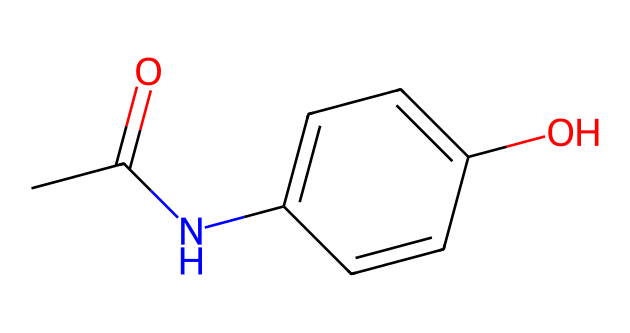What is the molecular formula of acetaminophen? The SMILES representation can be broken down to identify the components. There are two carbonyl (C) atoms from the acetyl group (CC(=O)) and a phenolic hydroxyl group (c1ccc(O)cc). Counting all atoms gives C8, H9, N1, O2. Therefore, the molecular formula is C8H9NO2.
Answer: C8H9NO2 How many rings are present in the structure of acetaminophen? In the SMILES string, "c" denotes aromatic carbon atoms that are part of a ring structure. There’s one set of "c" that forms a six-membered aromatic ring. There are no other rings present in the compound.
Answer: 1 What functional groups are present in acetaminophen? The structure depicts several functional groups: the acetyl (–C(=O)CH3) and amino (–NH) groups, and also a hydroxyl (–OH) group on the aromatic ring. These groups influence the compound's reactivity and properties.
Answer: acetyl, amino, hydroxyl What type of intermolecular forces can acetaminophen engage in? Due to the presence of hydroxyl and amino groups, acetaminophen can form hydrogen bonds. This is because it can donate and accept hydrogen ions, thus allowing for significant dipole interactions.
Answer: hydrogen bonds What is the role of the hydroxyl group in acetaminophen? The hydroxyl group (–OH) contributes to the solubility of acetaminophen in water and influences its pharmacological activity by participating in hydrogen bonding within biological systems.
Answer: solubility How many nitrogen atoms are in the structure of acetaminophen? To find the nitrogen atoms, examine the SMILES notation. There is one nitrogen atom denoted by "N" in the amide group, showing there is only one nitrogen in the entire structure.
Answer: 1 